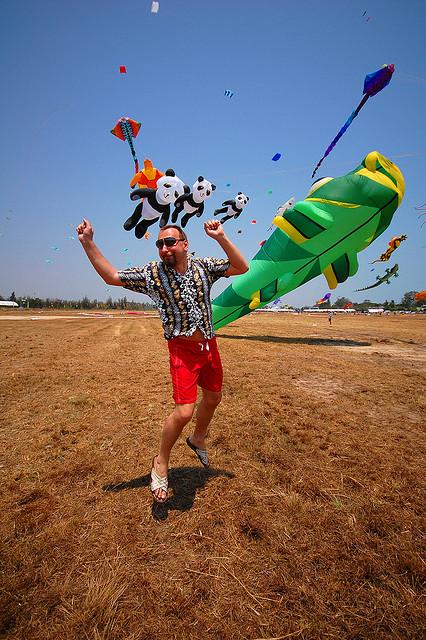How many pandas are there?
Quick response, please. 3. Is the man wearing shoes?
Answer briefly. Yes. What color is the fish kite?
Answer briefly. Green. 